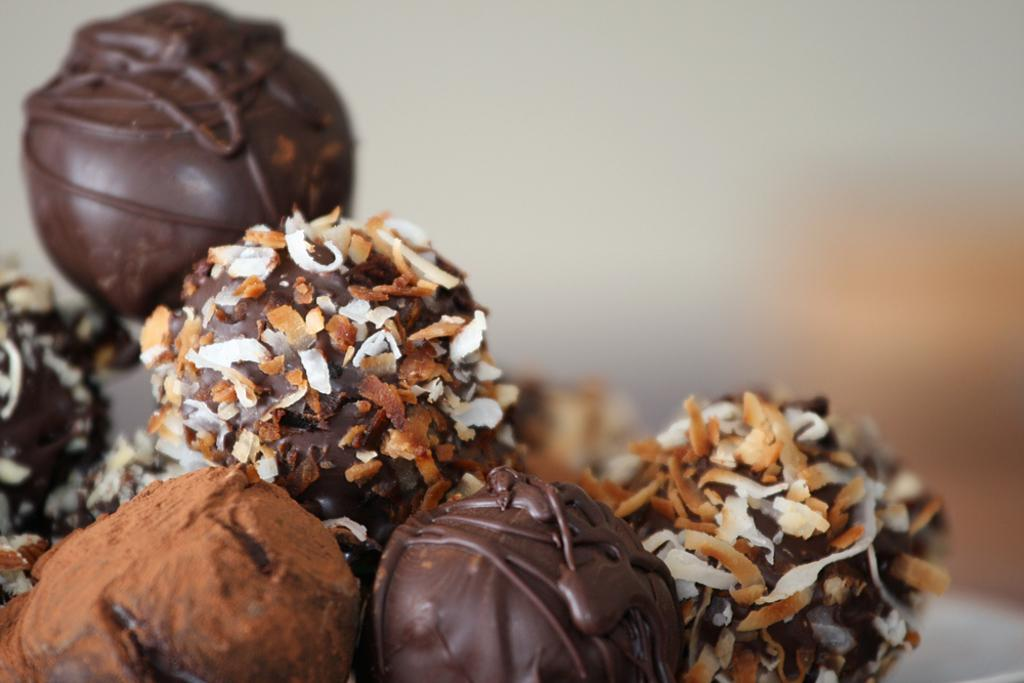What is the main subject of the image? The main subject of the image is chocolates. Can you describe the location of the chocolates in the image? The chocolates are at the center of the image. What advice does the writer give about the chocolates in the image? There is no writer present in the image, nor is there any advice given about the chocolates. 